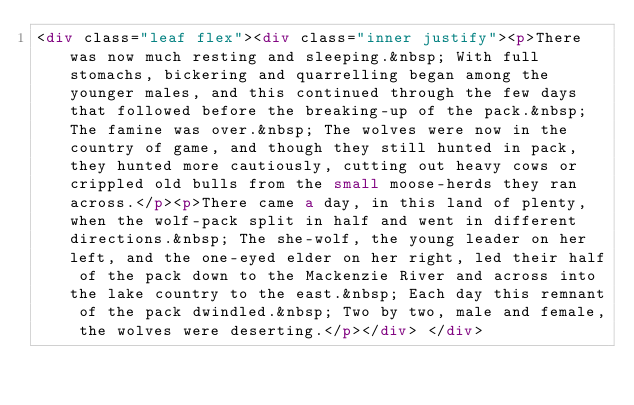<code> <loc_0><loc_0><loc_500><loc_500><_HTML_><div class="leaf flex"><div class="inner justify"><p>There was now much resting and sleeping.&nbsp; With full stomachs, bickering and quarrelling began among the younger males, and this continued through the few days that followed before the breaking-up of the pack.&nbsp; The famine was over.&nbsp; The wolves were now in the country of game, and though they still hunted in pack, they hunted more cautiously, cutting out heavy cows or crippled old bulls from the small moose-herds they ran across.</p><p>There came a day, in this land of plenty, when the wolf-pack split in half and went in different directions.&nbsp; The she-wolf, the young leader on her left, and the one-eyed elder on her right, led their half of the pack down to the Mackenzie River and across into the lake country to the east.&nbsp; Each day this remnant of the pack dwindled.&nbsp; Two by two, male and female, the wolves were deserting.</p></div> </div></code> 